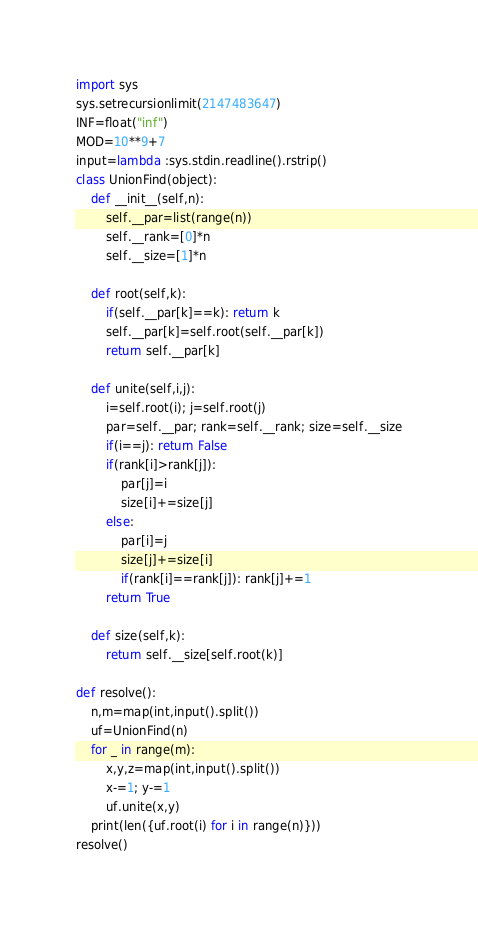Convert code to text. <code><loc_0><loc_0><loc_500><loc_500><_Python_>import sys
sys.setrecursionlimit(2147483647)
INF=float("inf")
MOD=10**9+7
input=lambda :sys.stdin.readline().rstrip()
class UnionFind(object):
    def __init__(self,n):
        self.__par=list(range(n))
        self.__rank=[0]*n
        self.__size=[1]*n

    def root(self,k):
        if(self.__par[k]==k): return k
        self.__par[k]=self.root(self.__par[k])
        return self.__par[k]

    def unite(self,i,j):
        i=self.root(i); j=self.root(j)
        par=self.__par; rank=self.__rank; size=self.__size
        if(i==j): return False
        if(rank[i]>rank[j]):
            par[j]=i
            size[i]+=size[j]
        else:
            par[i]=j
            size[j]+=size[i]
            if(rank[i]==rank[j]): rank[j]+=1
        return True

    def size(self,k):
        return self.__size[self.root(k)]

def resolve():
    n,m=map(int,input().split())
    uf=UnionFind(n)
    for _ in range(m):
        x,y,z=map(int,input().split())
        x-=1; y-=1
        uf.unite(x,y)
    print(len({uf.root(i) for i in range(n)}))
resolve()</code> 